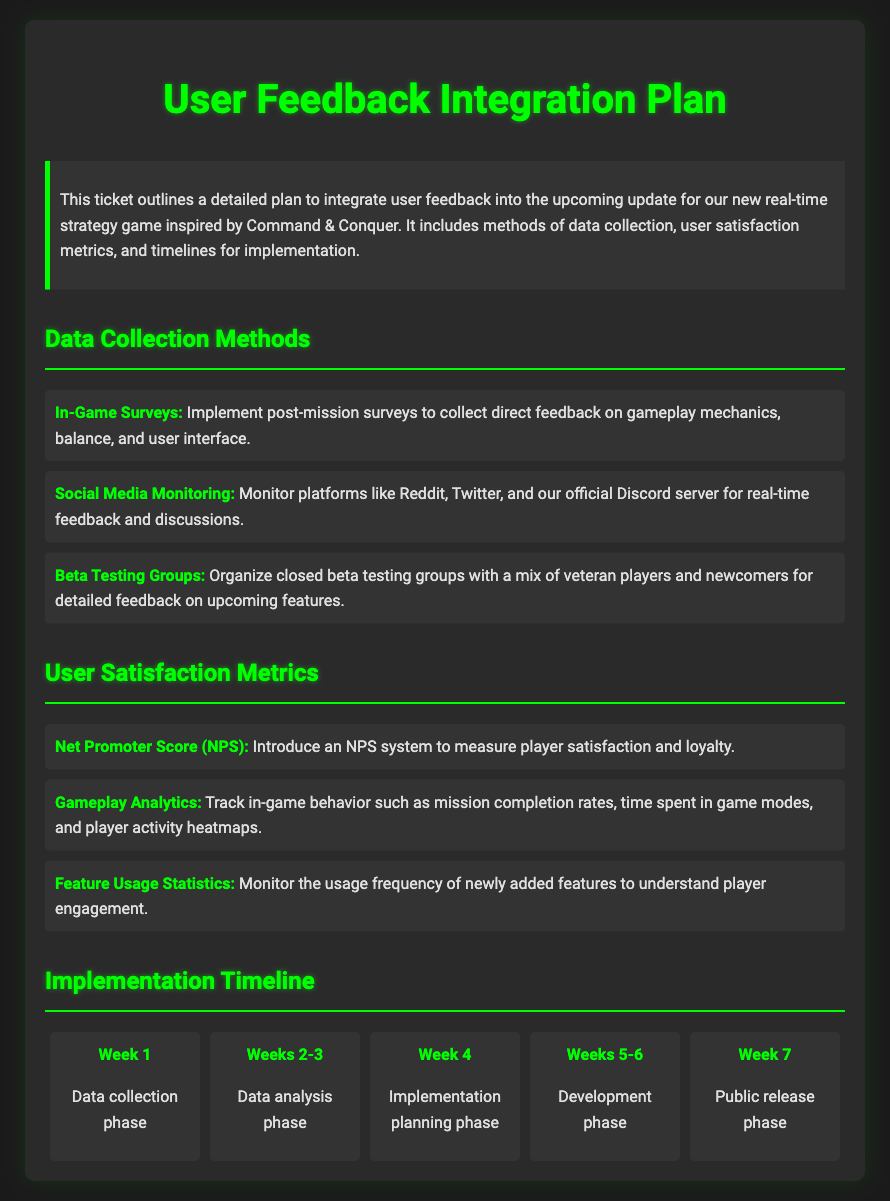What is the main purpose of the document? The document outlines a detailed plan to integrate user feedback into the upcoming update for the game.
Answer: Integration of user feedback What method is used for real-time feedback collection? The method mentioned is Social Media Monitoring to gather continuous player feedback.
Answer: Social Media Monitoring Which score is introduced to measure player satisfaction? The document states that a Net Promoter Score (NPS) system will be used.
Answer: Net Promoter Score How long is the data collection phase planned to last? The timeline indicates that the data collection phase will be completed in Week 1.
Answer: Week 1 What occurs during Weeks 2-3? According to the timeline, the data analysis phase takes place during this period.
Answer: Data analysis phase What type of players are included in Beta Testing Groups? The plan specifies a mix of veteran players and newcomers will be involved.
Answer: Veteran players and newcomers How many weeks are allocated for the development phase? The document mentions that the development phase spans Weeks 5-6.
Answer: Weeks 5-6 What is tracked to monitor player engagement? The document notes that feature usage statistics are monitored for player engagement.
Answer: Feature Usage Statistics What color format is used for headings in the document? Headings in the document use a green color format, as specified in the style.
Answer: Green color format 